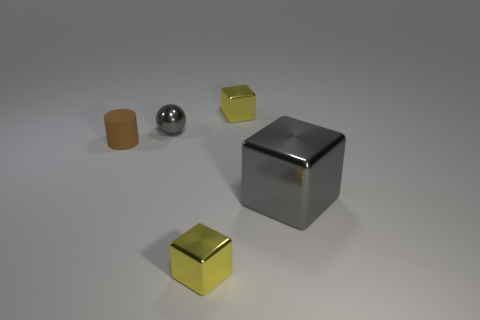Add 2 blocks. How many objects exist? 7 Subtract all cylinders. How many objects are left? 4 Subtract 0 cyan cubes. How many objects are left? 5 Subtract all gray metal objects. Subtract all gray metallic cubes. How many objects are left? 2 Add 3 yellow metallic blocks. How many yellow metallic blocks are left? 5 Add 4 big red balls. How many big red balls exist? 4 